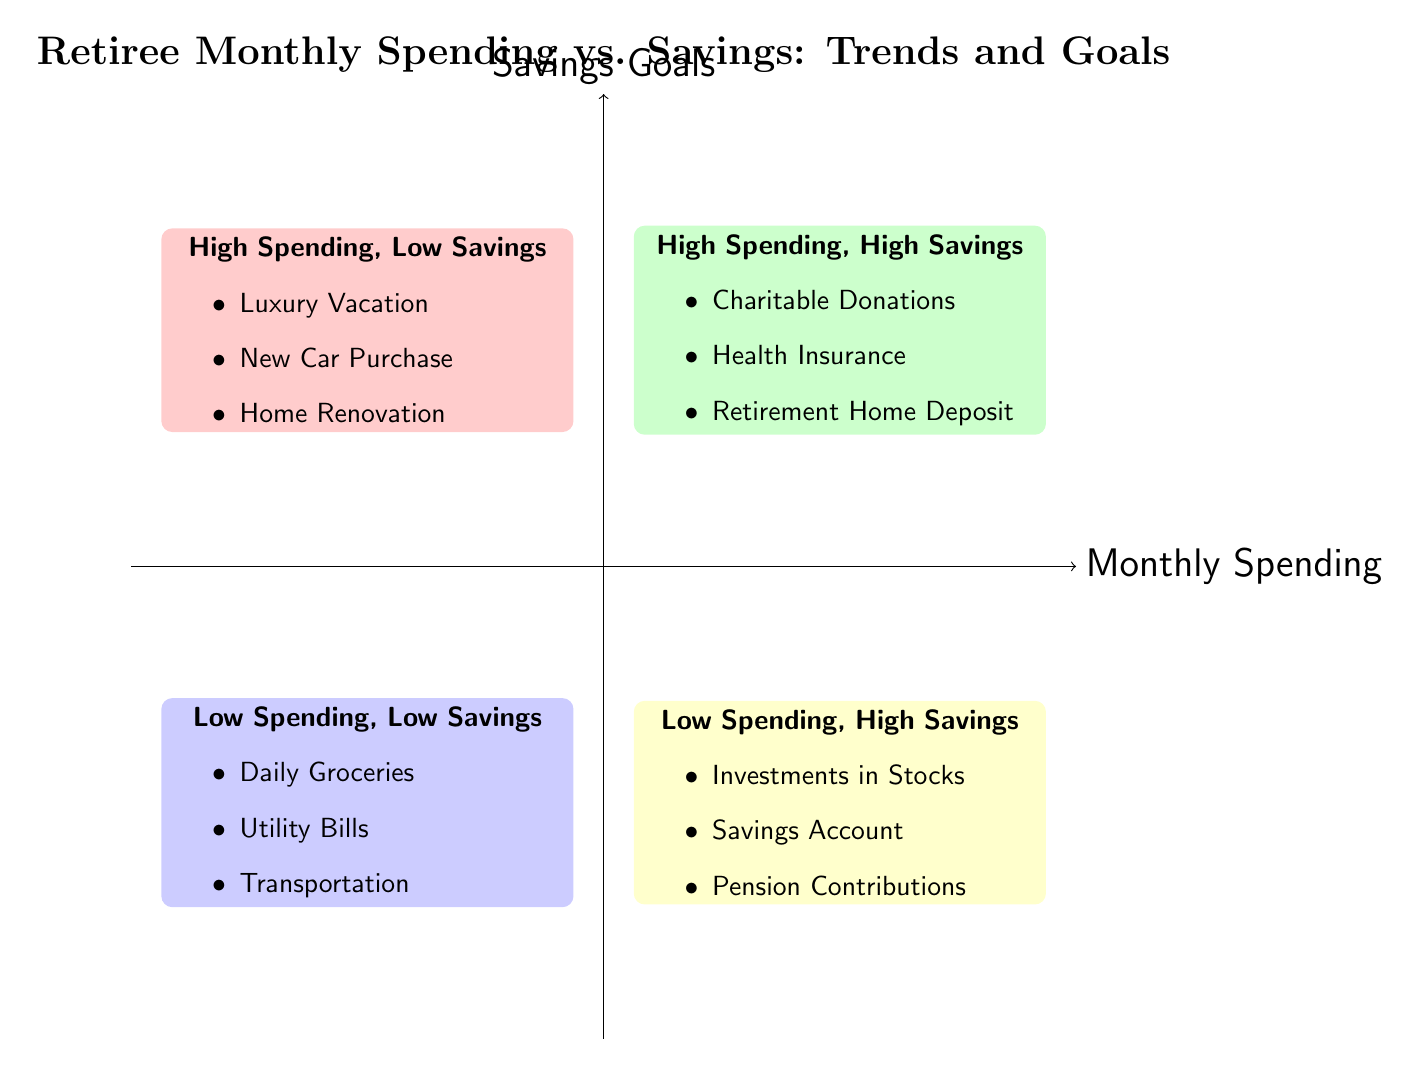What are the examples listed in the "High Spending, Low Savings" quadrant? The "High Spending, Low Savings" quadrant includes examples such as Luxury Vacation, New Car Purchase, and Home Renovation. These are clearly visible in the diagram.
Answer: Luxury Vacation, New Car Purchase, Home Renovation How many quadrants are represented in the diagram? The diagram features four distinct quadrants: High Spending, Low Savings; High Spending, High Savings; Low Spending, Low Savings; and Low Spending, High Savings. This information can be counted directly from the diagram.
Answer: 4 Which quadrant includes "Savings Account"? "Savings Account" is an example listed in the "Low Spending, High Savings" quadrant. This can be identified by checking the examples in each quadrant.
Answer: Low Spending, High Savings What is the relationship between spending and savings in the "High Spending, High Savings" quadrant? In the "High Spending, High Savings" quadrant, both spending and savings are high, indicating a positive financial activity where individuals are able to spend while also achieving significant savings. This relationship is inherent to the positioning of the quadrant.
Answer: Both high What type of expenditures are noted in the "Low Spending, Low Savings" quadrant? The "Low Spending, Low Savings" quadrant mentions expenditures like Daily Groceries, Utility Bills, and Transportation, which are typically everyday expenses. This is articulated by examining the examples listed in that specific quadrant.
Answer: Daily Groceries, Utility Bills, Transportation Which quadrant would likely represent charitable donations? Charitable Donations are specifically listed in the "High Spending, High Savings" quadrant, reflecting a situation where an individual is willing to spend on philanthropic activities while maintaining high savings. This can be confirmed by locating the example within the quadrant.
Answer: High Spending, High Savings Which quadrant has investments as an example? Investments are exemplified in the "Low Spending, High Savings" quadrant, denoting a strategy where individuals invest money with low current expenditures while focusing on increasing savings. This can be confirmed by referring to the examples in that quadrant.
Answer: Low Spending, High Savings How does the diagram illustrate savings goals? The diagram illustrates savings goals by using the vertical axis labeled "Savings Goals," which categorizes expenditures with respect to their savings benefits across the four quadrants. This can be understood by analyzing how each quadrant is positioned relative to that axis.
Answer: Vertical axis What type of spending does the "High Spending, Low Savings" quadrant emphasize? The "High Spending, Low Savings" quadrant emphasizes luxury and significant one-time purchases such as vacations and car purchases, highlighting a lack of savings despite high expenditures. This can be identified through the examples provided in that quadrant.
Answer: Luxury purchases 